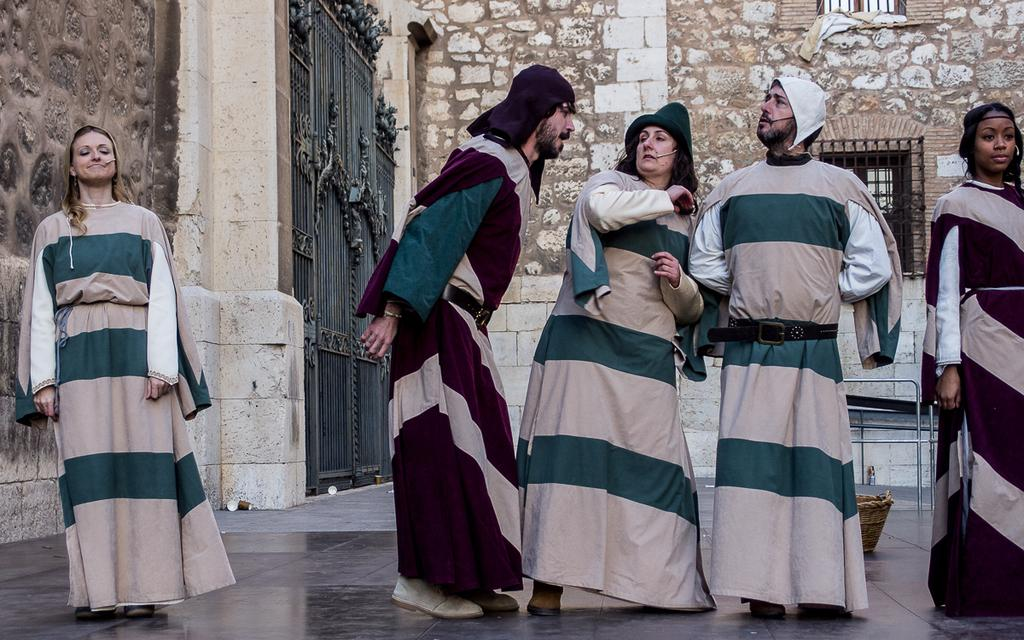How many people are in the image? There are five persons standing in the image. What can be seen on the floor in the background? There is a basket on the floor in the background. What objects are present in the background? Iron rods and gates are visible in the background. What type of structure is in the background? There is a building in the background. What time of day is it in the image, and can you see a wave in the background? The time of day is not mentioned in the image, and there is no wave visible in the background. Is there a field of corn growing near the building in the background? There is no mention of corn or a field in the image. 